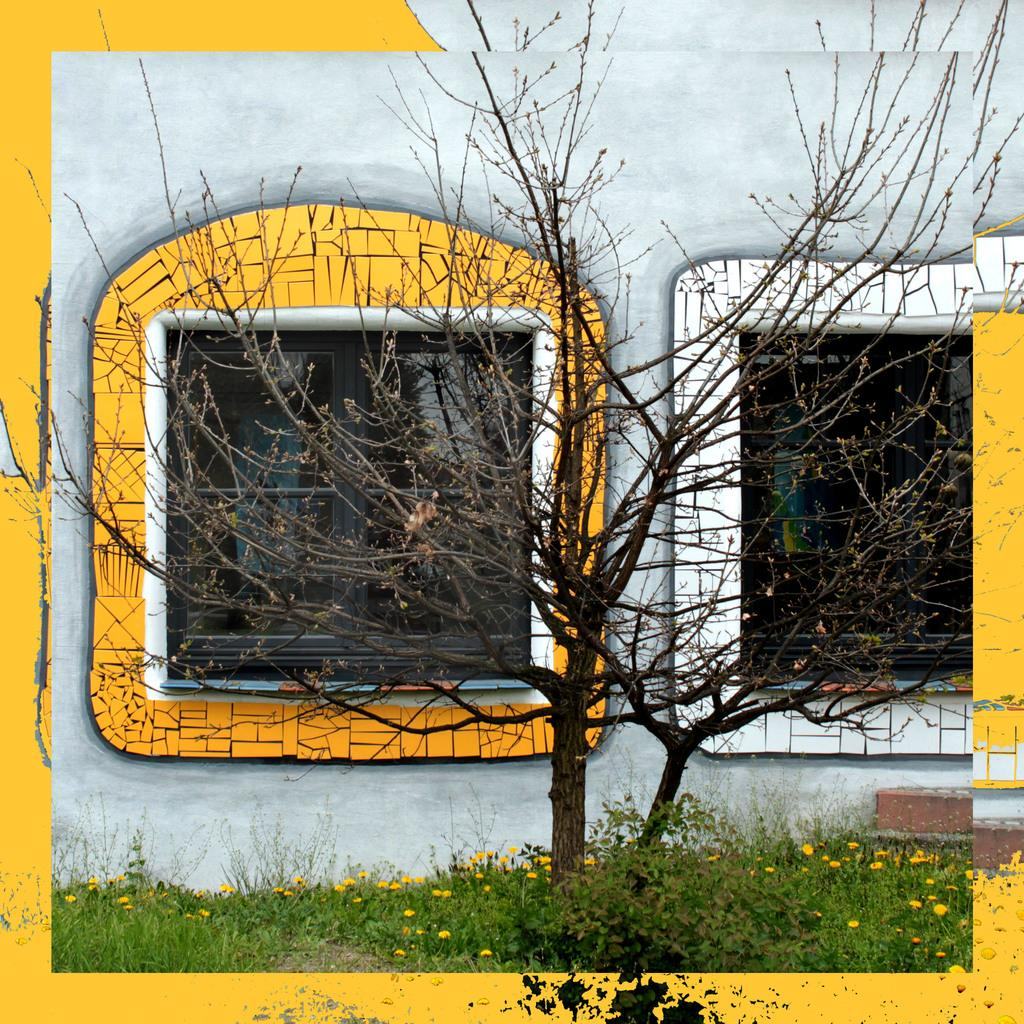What type of vegetation is present in the image? There are trees with branches and small plants with yellow flowers in the image. What architectural features can be seen in the image? There are windows and a wall in the image. How many beds are visible in the image? There are no beds present in the image. Can you describe the kitty playing with the men in the image? There is no kitty or men present in the image. 